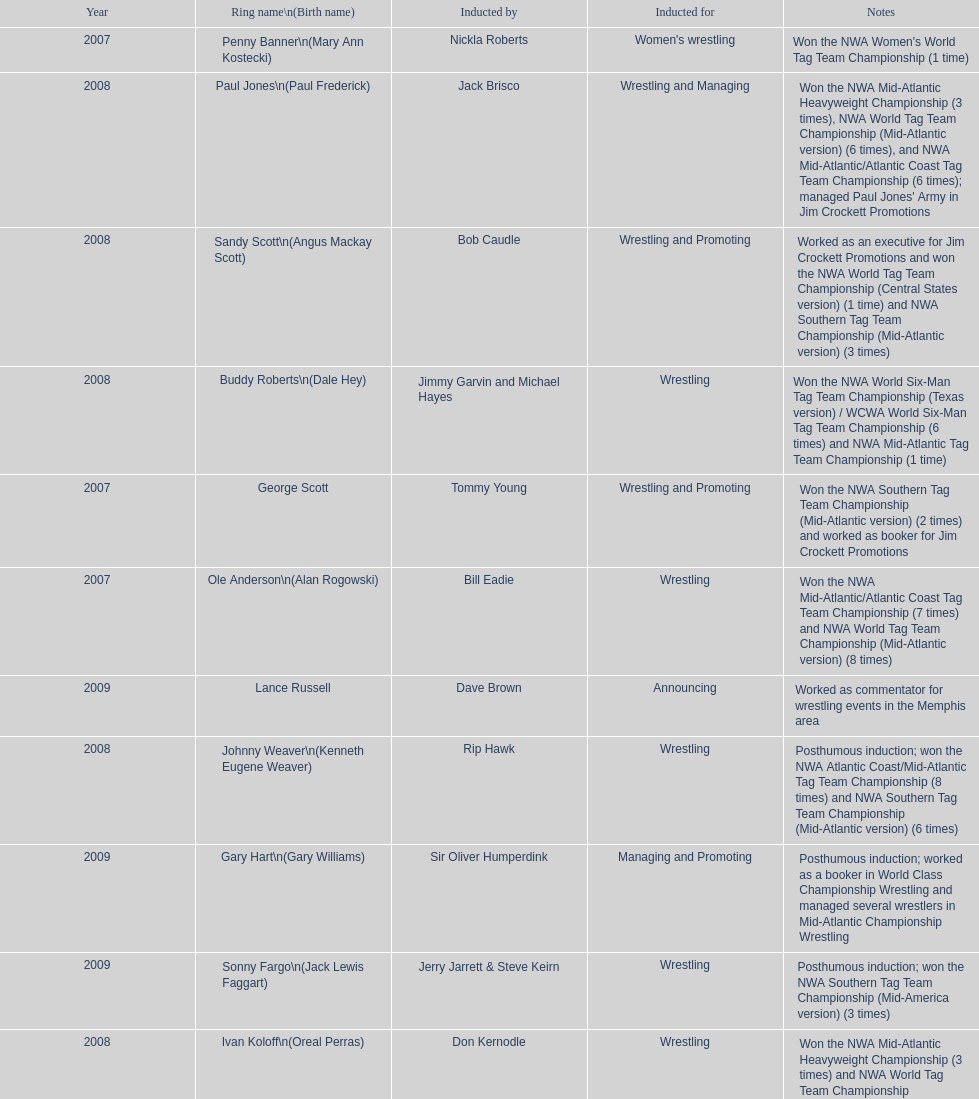Who's real name is dale hey, grizzly smith or buddy roberts? Buddy Roberts. 